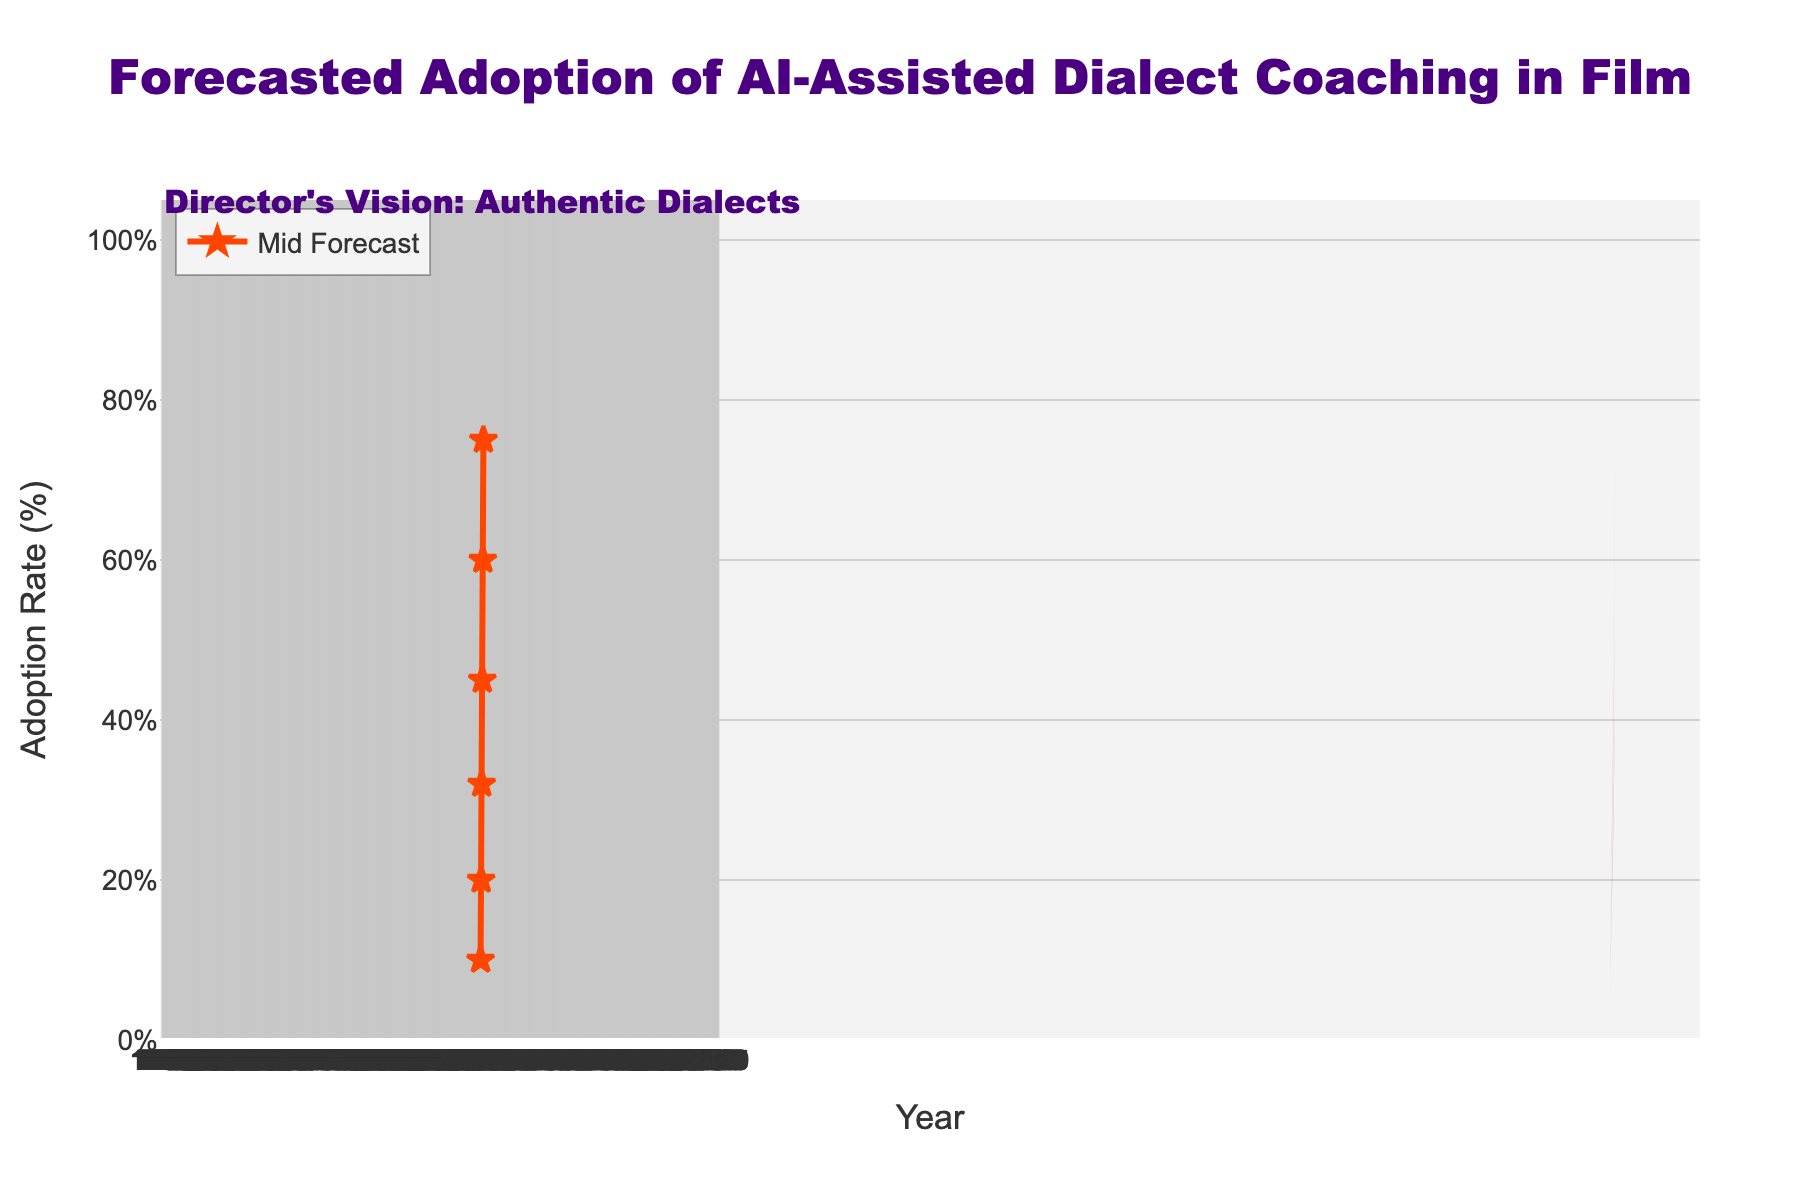what is the title of the figure? The title of the figure is usually placed at the top and written in a larger and bold font. In this case, the title is "Forecasted Adoption of AI-Assisted Dialect Coaching in Film", which is found at the top center of the plot.
Answer: Forecasted Adoption of AI-Assisted Dialect Coaching in Film What is the predicted mid adoption rate for the year 2025? Looking for the mid adoption rate in the year 2025 involves finding the "Mid" value on the y-axis corresponding to the year 2025 on the x-axis. It is 32.
Answer: 32 Which year shows the largest range between the low and high adoption rate estimates? To determine the year with the largest range, find the difference between the high and low estimates for each year. In 2028, the range is the largest (100 - 45 = 55 percentage points), which is greater than the ranges in other years.
Answer: 2028 How does the mid forecast adoption rate change from 2023 to 2028? To find the change in the mid forecast adoption rate from 2023 to 2028, subtract the mid rate for 2023 from the mid rate for 2028. The change is 75 - 10 = 65 percentage points.
Answer: 65 What adoption rate is highlighted with markers on the plot? The adoption rate highlighted with markers corresponds to the mid forecast, as evident from the plotted lines with star-shaped markers.
Answer: Mid forecast Between 2024 and 2026, in which year is the mid-high forecast the closest to the actual mid forecast? By comparing the mid-high forecast values to the mid forecast values for the years 2024, 2025, and 2026: 25 (2024), 40 (2025), 55 (2026), it's evident that 25-20 = 5 percentage points, 40-32 = 8 percentage points, and 55-45 = 10 percentage points respectively. So, in the year 2024, the mid-high forecast is closest to the mid forecast.
Answer: 2024 What is the trend of the adoption rates over the years based on the forecasted data? The different scenarios (low, low-mid, mid, mid-high, high) all show an increasing trend in adoption rates from 2023 to 2028, with the adoption rate consistently going up each year across all forecast levels.
Answer: Increasing trend In which year is the low forecast closest to 50%? By examining the low forecast data, it can be seen that in 2028, the low forecast (45%) is the closest to 50%.
Answer: 2028 How do the low-mid and mid-high forecasts compare in 2026? For the year 2026, the low-mid forecast is 35, and the mid-high forecast is 55. Comparing these two values, we see that the mid-high forecast is 20 percentage points higher than the low-mid forecast.
Answer: Mid-high is higher by 20 percentage points 